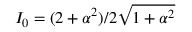<formula> <loc_0><loc_0><loc_500><loc_500>I _ { 0 } = ( 2 + \alpha ^ { 2 } ) / 2 \sqrt { 1 + \alpha ^ { 2 } }</formula> 